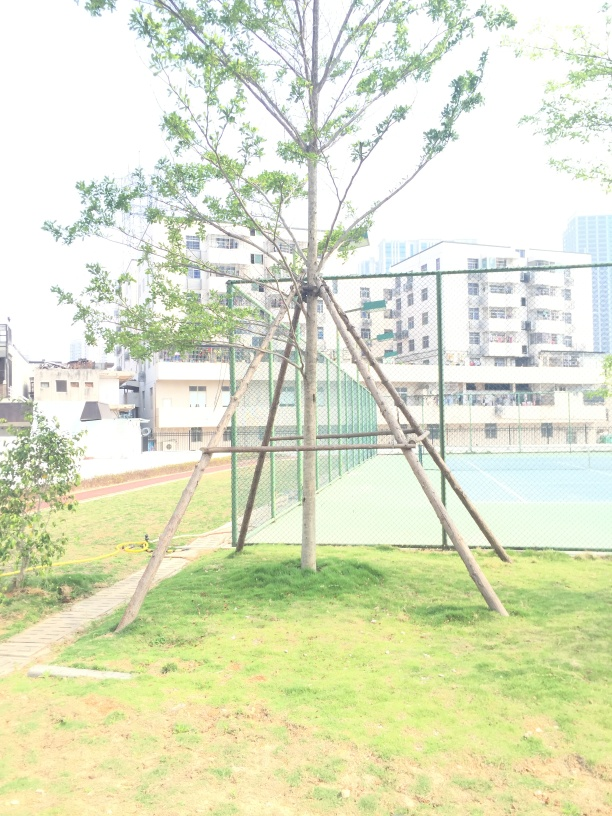Can you tell what season it might be in this photo? The tree is full of green leaves, which usually indicates spring or summer. The absence of fallen leaves or bare branches supports this observation. 